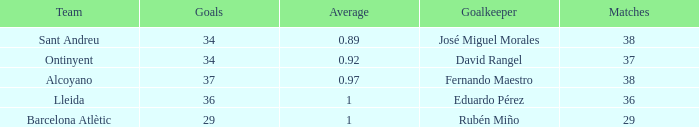What is the sum of Goals, when Matches is less than 29? None. 